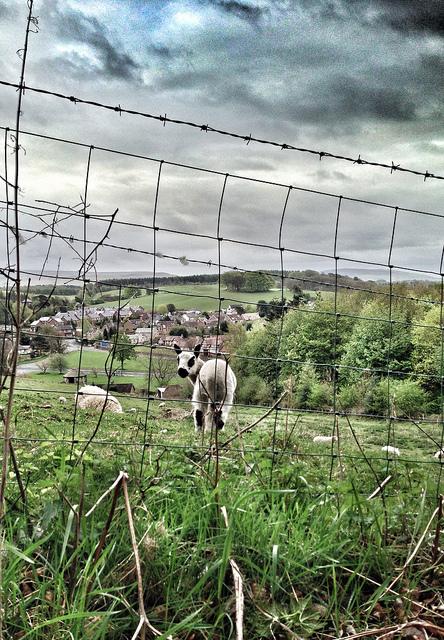What is the weather like here?
Quick response, please. Cloudy. What kind of fence is this?
Keep it brief. Barbed wire. What type of animal is this?
Be succinct. Sheep. 